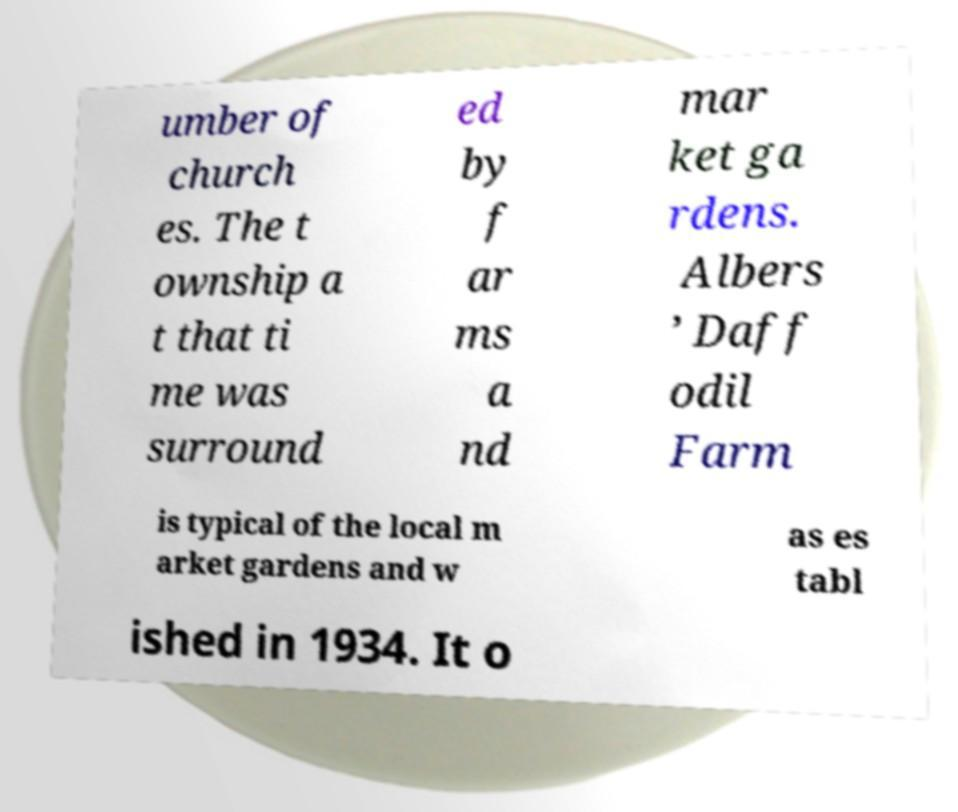I need the written content from this picture converted into text. Can you do that? umber of church es. The t ownship a t that ti me was surround ed by f ar ms a nd mar ket ga rdens. Albers ’ Daff odil Farm is typical of the local m arket gardens and w as es tabl ished in 1934. It o 